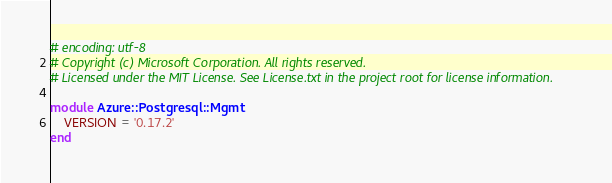<code> <loc_0><loc_0><loc_500><loc_500><_Ruby_># encoding: utf-8
# Copyright (c) Microsoft Corporation. All rights reserved.
# Licensed under the MIT License. See License.txt in the project root for license information.

module Azure::Postgresql::Mgmt
    VERSION = '0.17.2'
end
</code> 